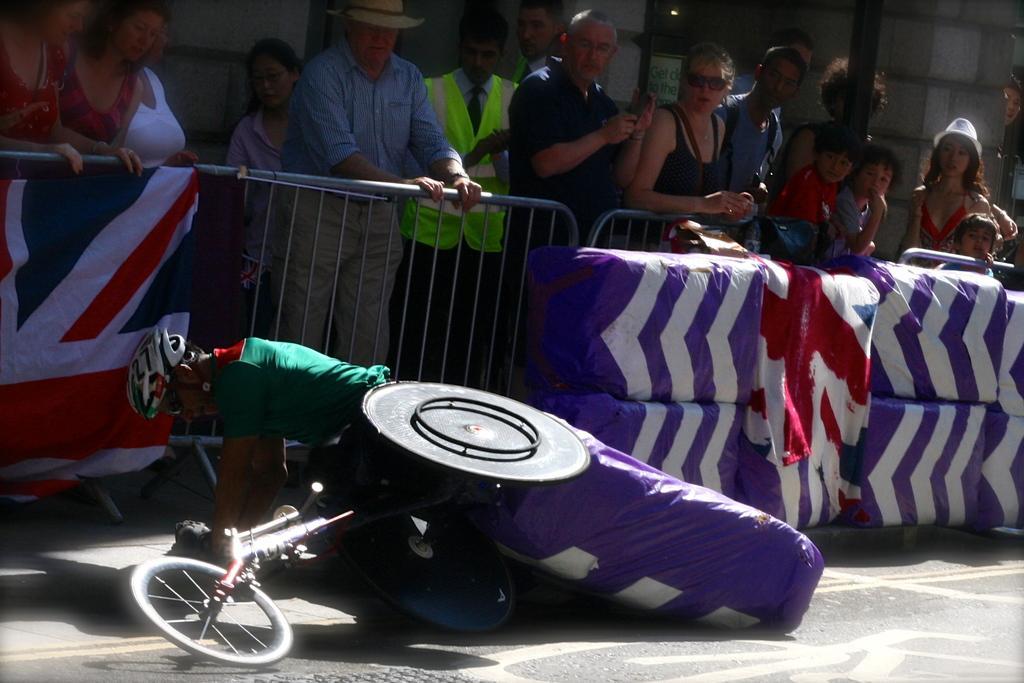Can you describe this image briefly? In this image I can see a vehicle and a person wearing green t shirt and white helmet on the ground. In the background I can see the railing, few objects which are violet and white in color and few persons standing on the other side of the railing. I can see few flags and the wall. 